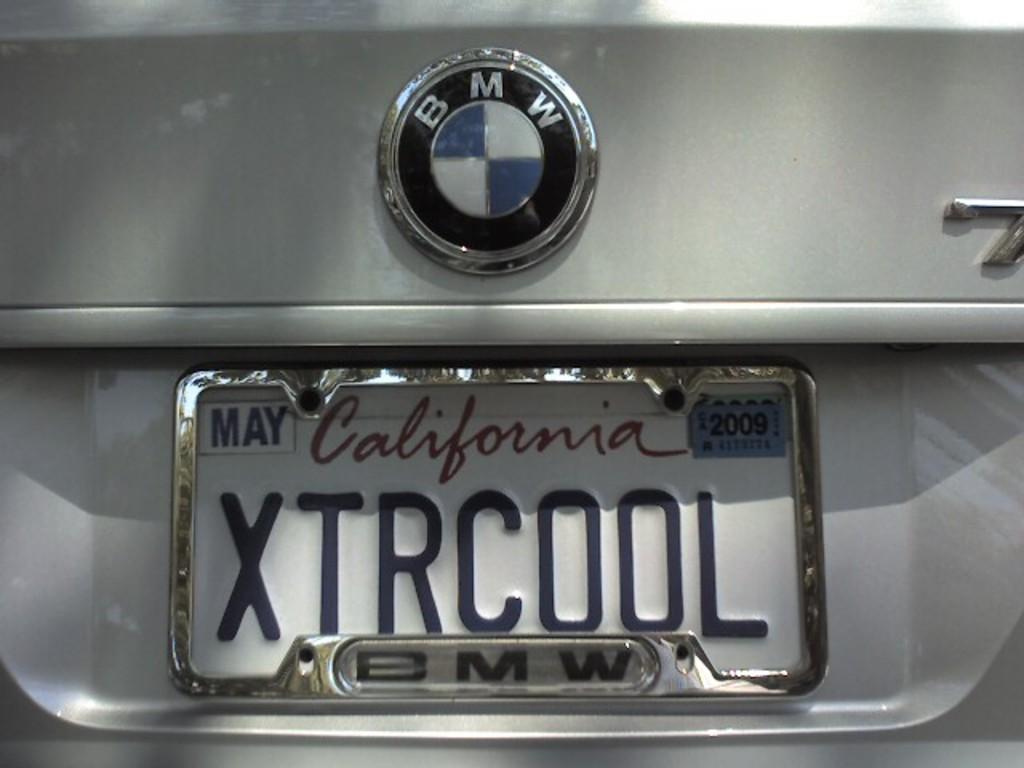How would you summarize this image in a sentence or two? We can see a car, on this car we can see number plate and logo. 